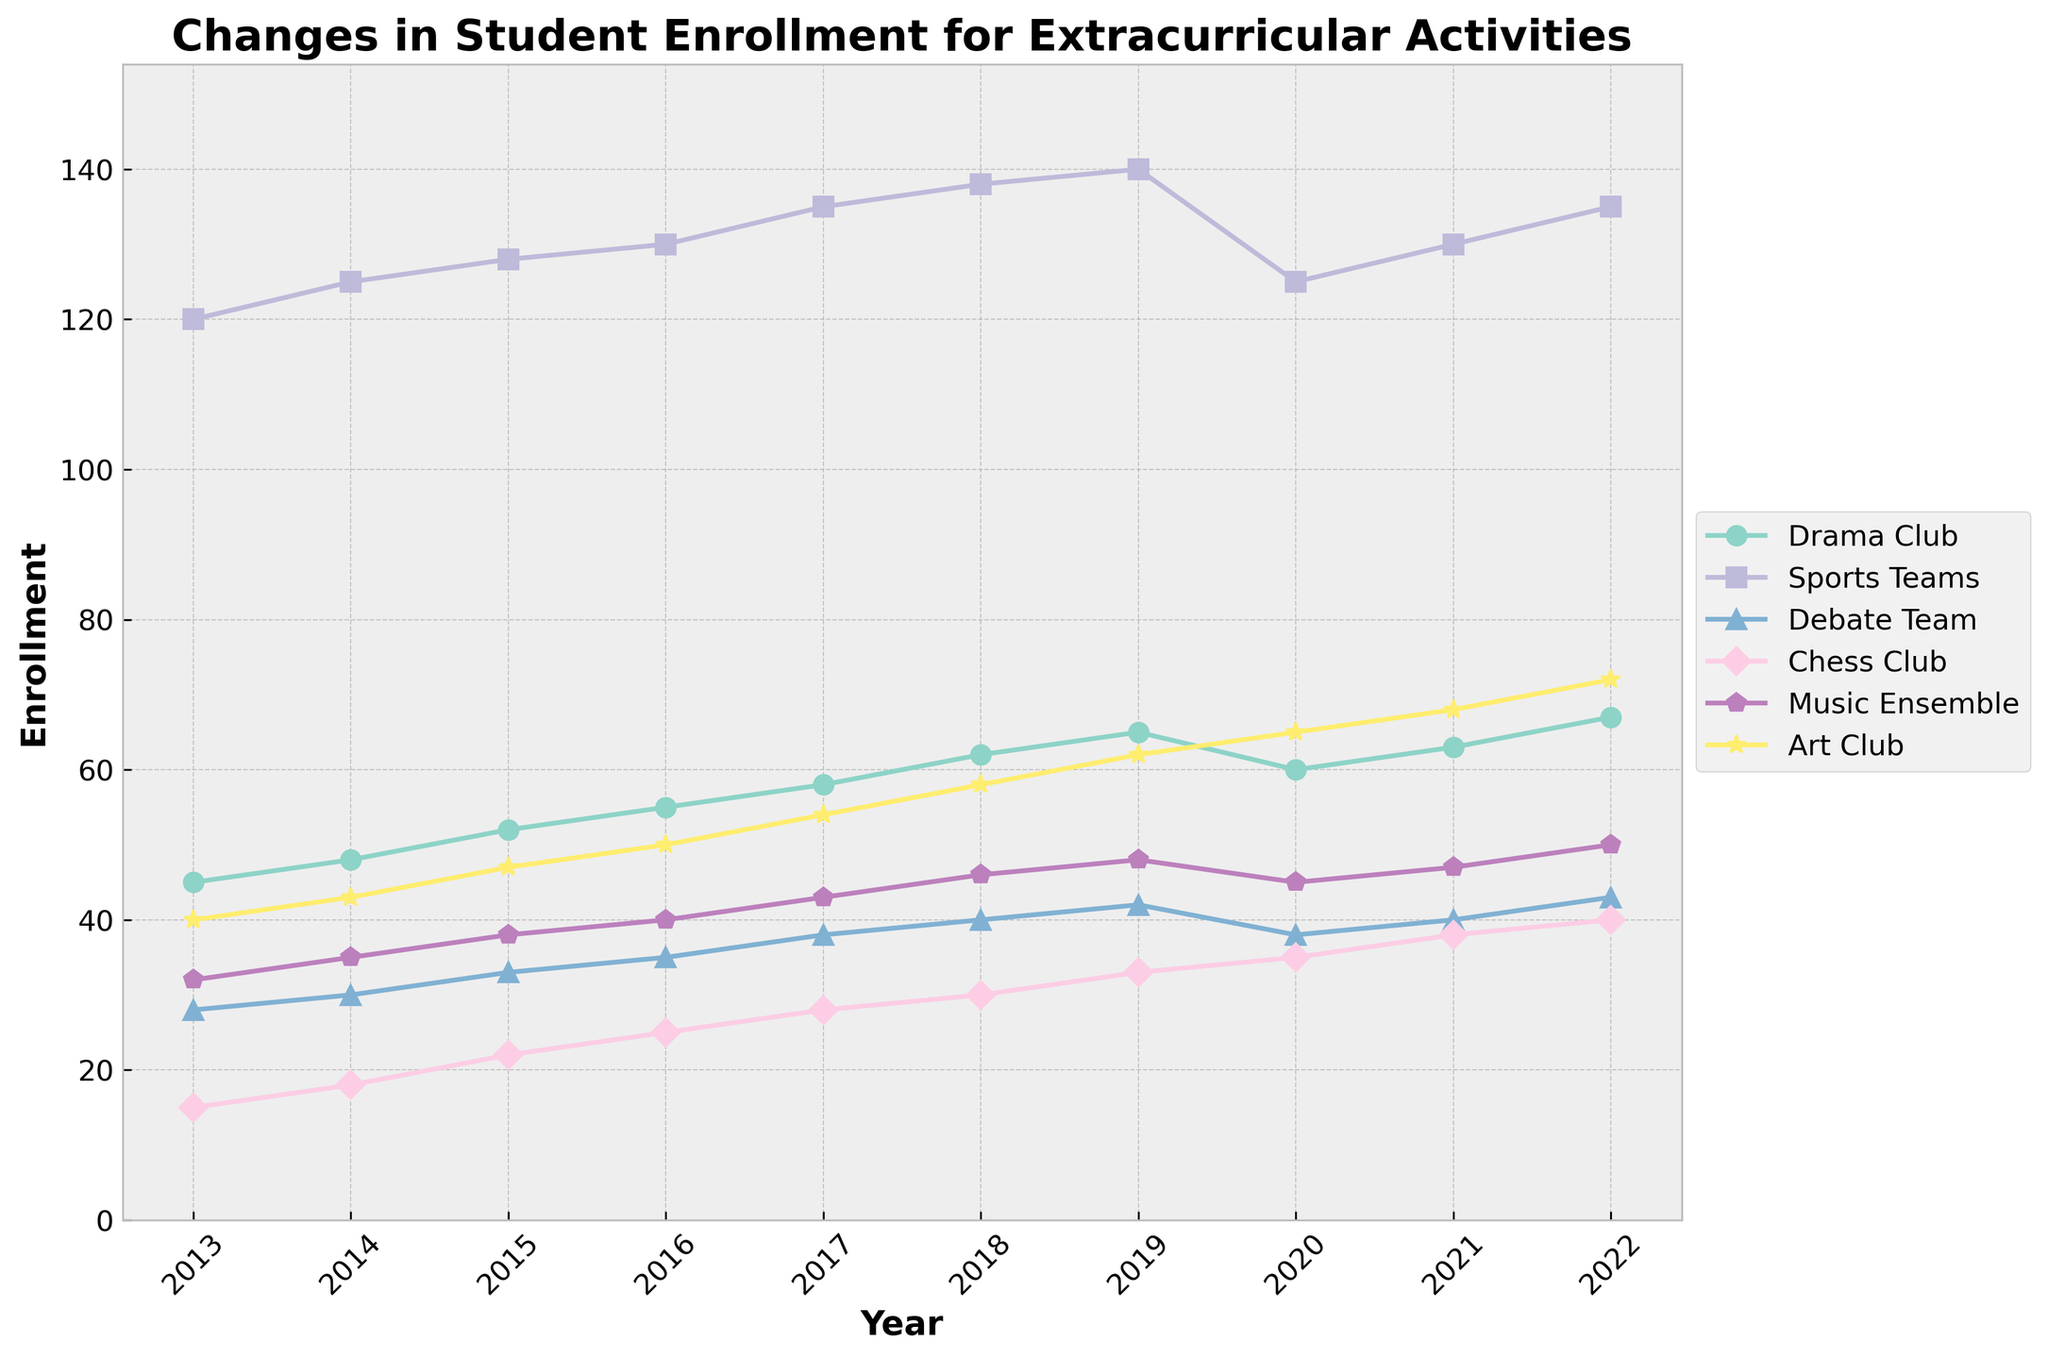What extracurricular activity had the highest enrollment in 2022? By looking at the year 2022 on the x-axis and comparing the y-values of all the lines, the highest point corresponds to the Sports Teams line.
Answer: Sports Teams Compare the enrollment changes for the Debate Team and the Chess Club between 2019 and 2020. For the Debate Team, enrollment decreased from 42 to 38, a change of -4. For the Chess Club, enrollment increased from 33 to 35, a change of +2.
Answer: Debate Team -4, Chess Club +2 Which activity had the greatest increase in enrollment from 2013 to 2022? To find this, we calculate the difference between 2022 and 2013 for each activity: Drama Club (67-45=22), Sports Teams (135-120=15), Debate Team (43-28=15), Chess Club (40-15=25), Music Ensemble (50-32=18), Art Club (72-40=32). The greatest increase is for Art Club at 32.
Answer: Art Club Which two activities had equal enrollment in any given year? Specify the year and enrollment. By comparing the values for each year, in 2020, both Drama Club and Debate Team had an enrollment of 38.
Answer: 2020, 38 What was the average enrollment for the Sports Teams over the entire decade? The sum of enrollments for Sports Teams across all years is (120 + 125 + 128 + 130 + 135 + 138 + 140 + 125 + 130 + 135) = 1306. Dividing by the number of years (10) gives the average 1306/10 = 130.6
Answer: 130.6 Which activity showed a sudden decrease in enrollment in 2020 and by how much? Comparing the values from 2019 to 2020, the Sports Teams enrollment dropped from 140 to 125, a sudden decrease of 15.
Answer: Sports Teams, 15 How did the Music Ensemble enrollment trend change from 2019 to 2020 and from 2020 to 2021? From 2019 to 2020, the Music Ensemble enrollment decreased from 48 to 45 (-3). From 2020 to 2021, it increased from 45 to 47 (+2).
Answer: -3, +2 What were the enrollment numbers for the Art Club in 2017, and how did it change by 2022? The enrollment for Art Club in 2017 was 54. By 2022, it increased to 72. The change is 72 - 54 = 18.
Answer: 18 Which activity had the least enrollment in 2015? By looking at the year 2015, the lowest y-value corresponds to the Chess Club with 22 enrollments.
Answer: Chess Club What’s the average enrollment for the Drama Club from 2013 to 2022? The sum of enrollments for Drama Club over the years is (45 + 48 + 52 + 55 + 58 + 62 + 65 + 60 + 63 + 67) = 575. Dividing by the number of years (10) gives the average 575/10 = 57.5
Answer: 57.5 